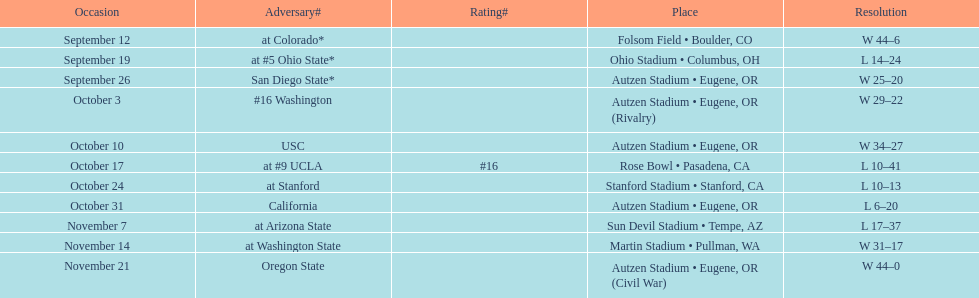Could you parse the entire table? {'header': ['Occasion', 'Adversary#', 'Rating#', 'Place', 'Resolution'], 'rows': [['September 12', 'at\xa0Colorado*', '', 'Folsom Field • Boulder, CO', 'W\xa044–6'], ['September 19', 'at\xa0#5\xa0Ohio State*', '', 'Ohio Stadium • Columbus, OH', 'L\xa014–24'], ['September 26', 'San Diego State*', '', 'Autzen Stadium • Eugene, OR', 'W\xa025–20'], ['October 3', '#16\xa0Washington', '', 'Autzen Stadium • Eugene, OR (Rivalry)', 'W\xa029–22'], ['October 10', 'USC', '', 'Autzen Stadium • Eugene, OR', 'W\xa034–27'], ['October 17', 'at\xa0#9\xa0UCLA', '#16', 'Rose Bowl • Pasadena, CA', 'L\xa010–41'], ['October 24', 'at\xa0Stanford', '', 'Stanford Stadium • Stanford, CA', 'L\xa010–13'], ['October 31', 'California', '', 'Autzen Stadium • Eugene, OR', 'L\xa06–20'], ['November 7', 'at\xa0Arizona State', '', 'Sun Devil Stadium • Tempe, AZ', 'L\xa017–37'], ['November 14', 'at\xa0Washington State', '', 'Martin Stadium • Pullman, WA', 'W\xa031–17'], ['November 21', 'Oregon State', '', 'Autzen Stadium • Eugene, OR (Civil War)', 'W\xa044–0']]} How many wins are listed for the season? 6. 